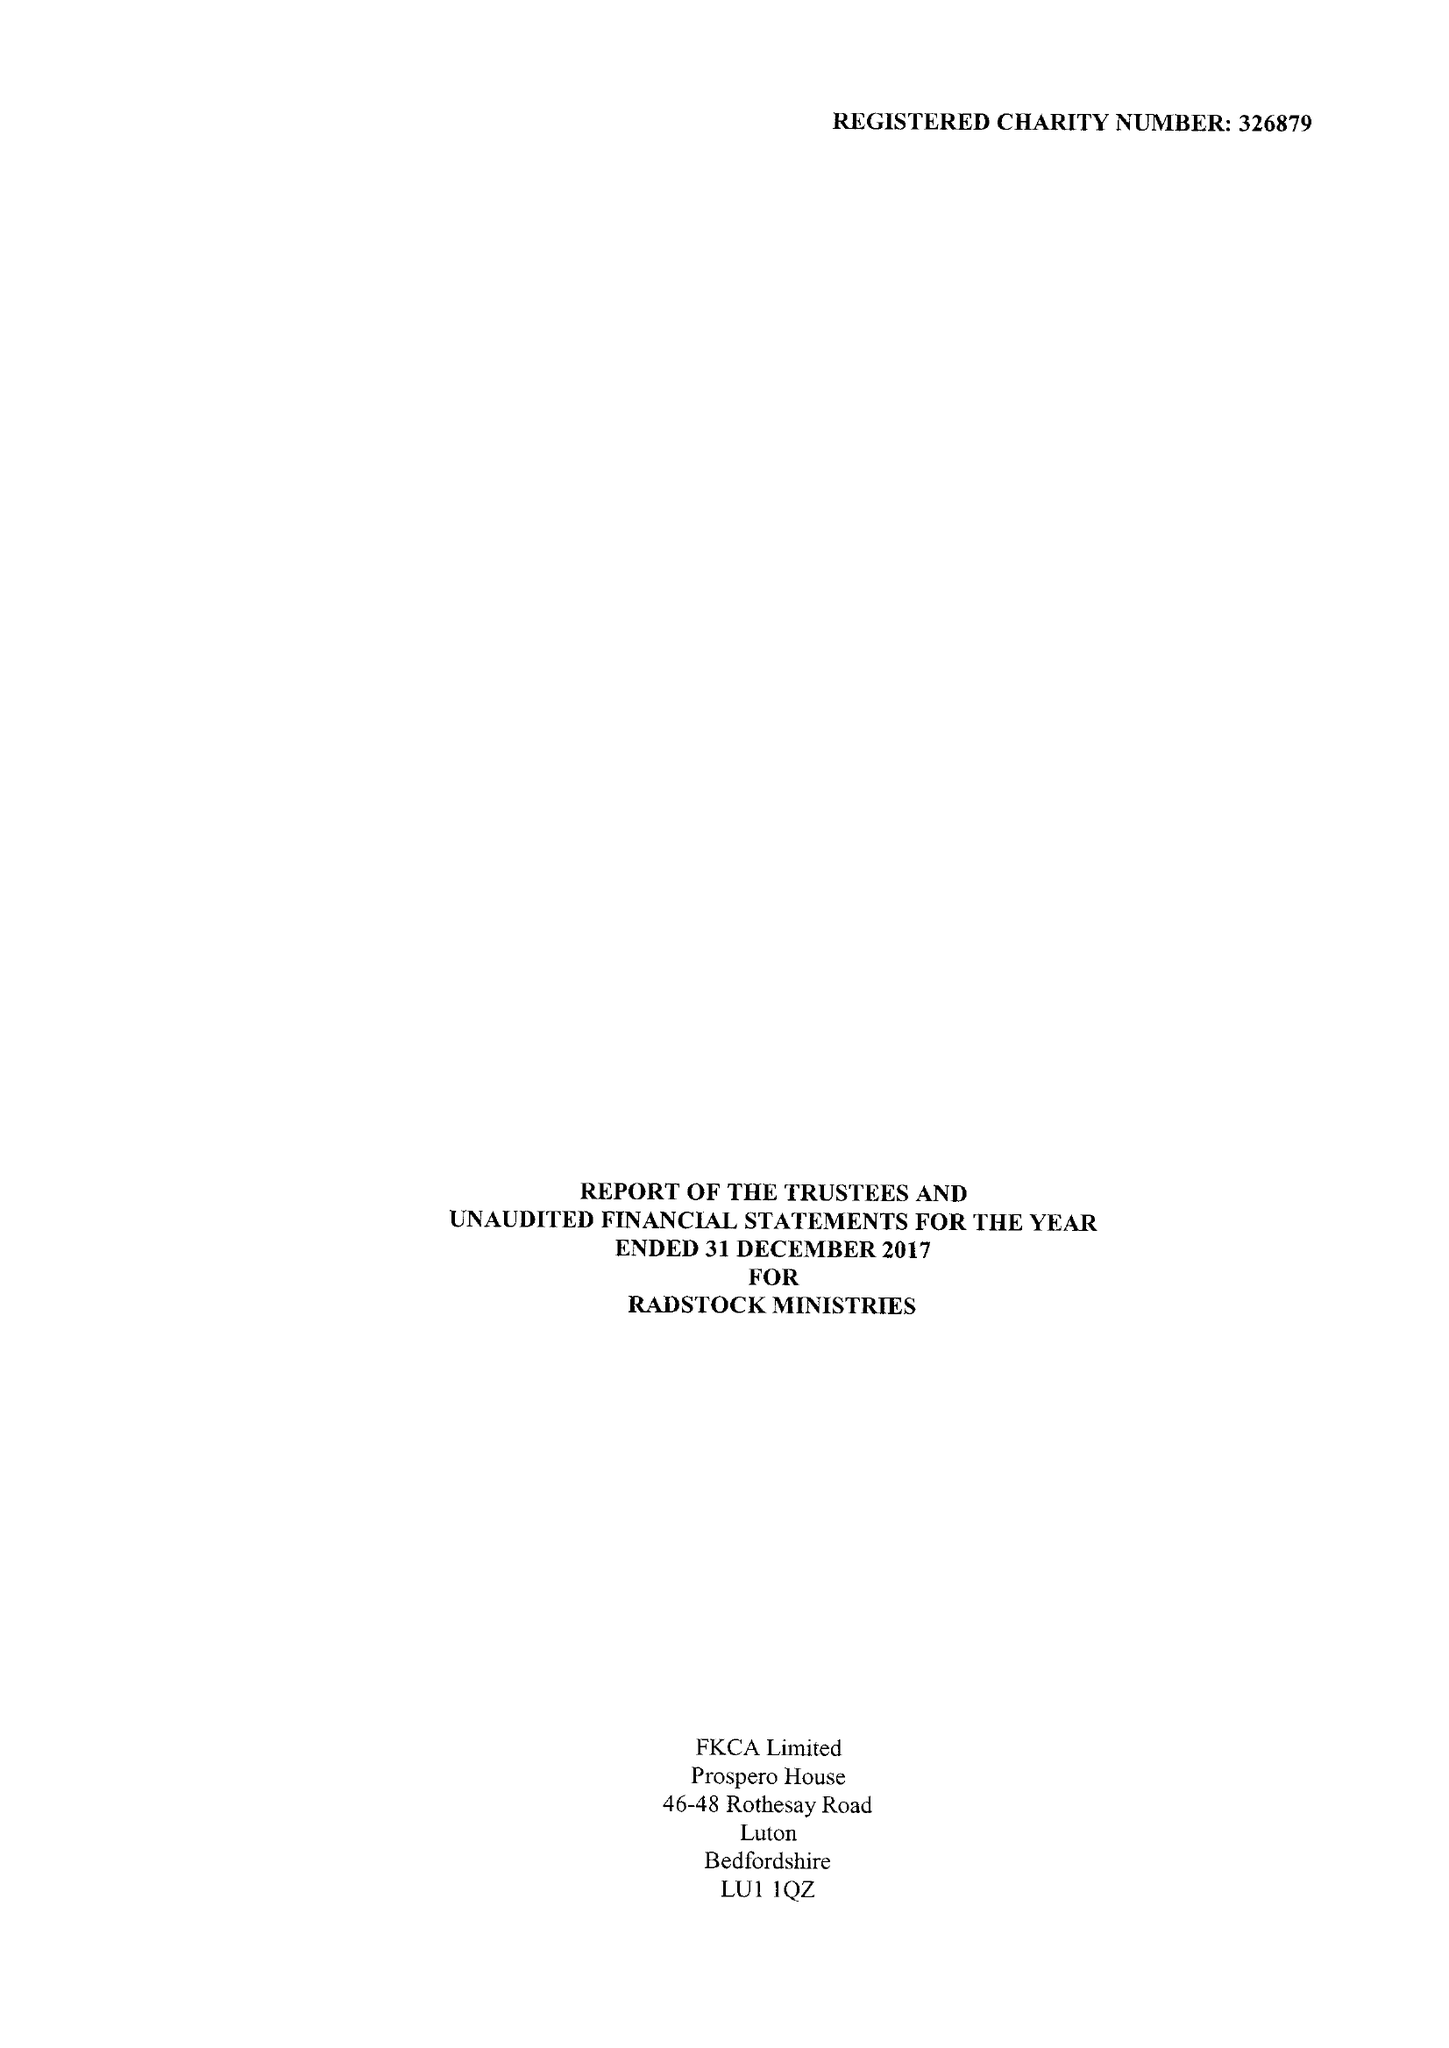What is the value for the address__postcode?
Answer the question using a single word or phrase. LU2 7XP 